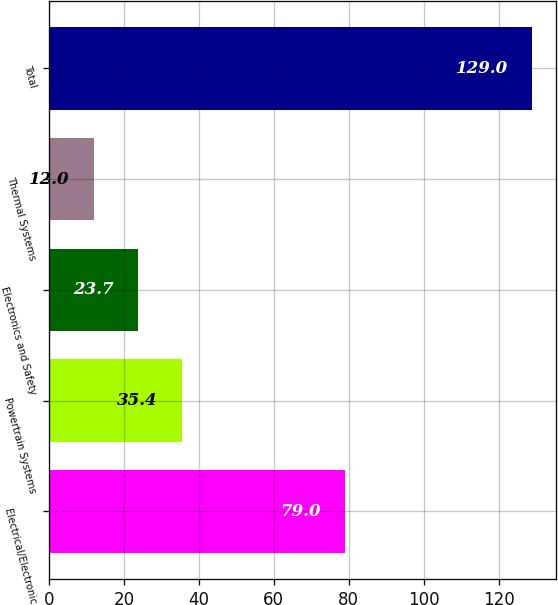Convert chart to OTSL. <chart><loc_0><loc_0><loc_500><loc_500><bar_chart><fcel>Electrical/Electronic<fcel>Powertrain Systems<fcel>Electronics and Safety<fcel>Thermal Systems<fcel>Total<nl><fcel>79<fcel>35.4<fcel>23.7<fcel>12<fcel>129<nl></chart> 